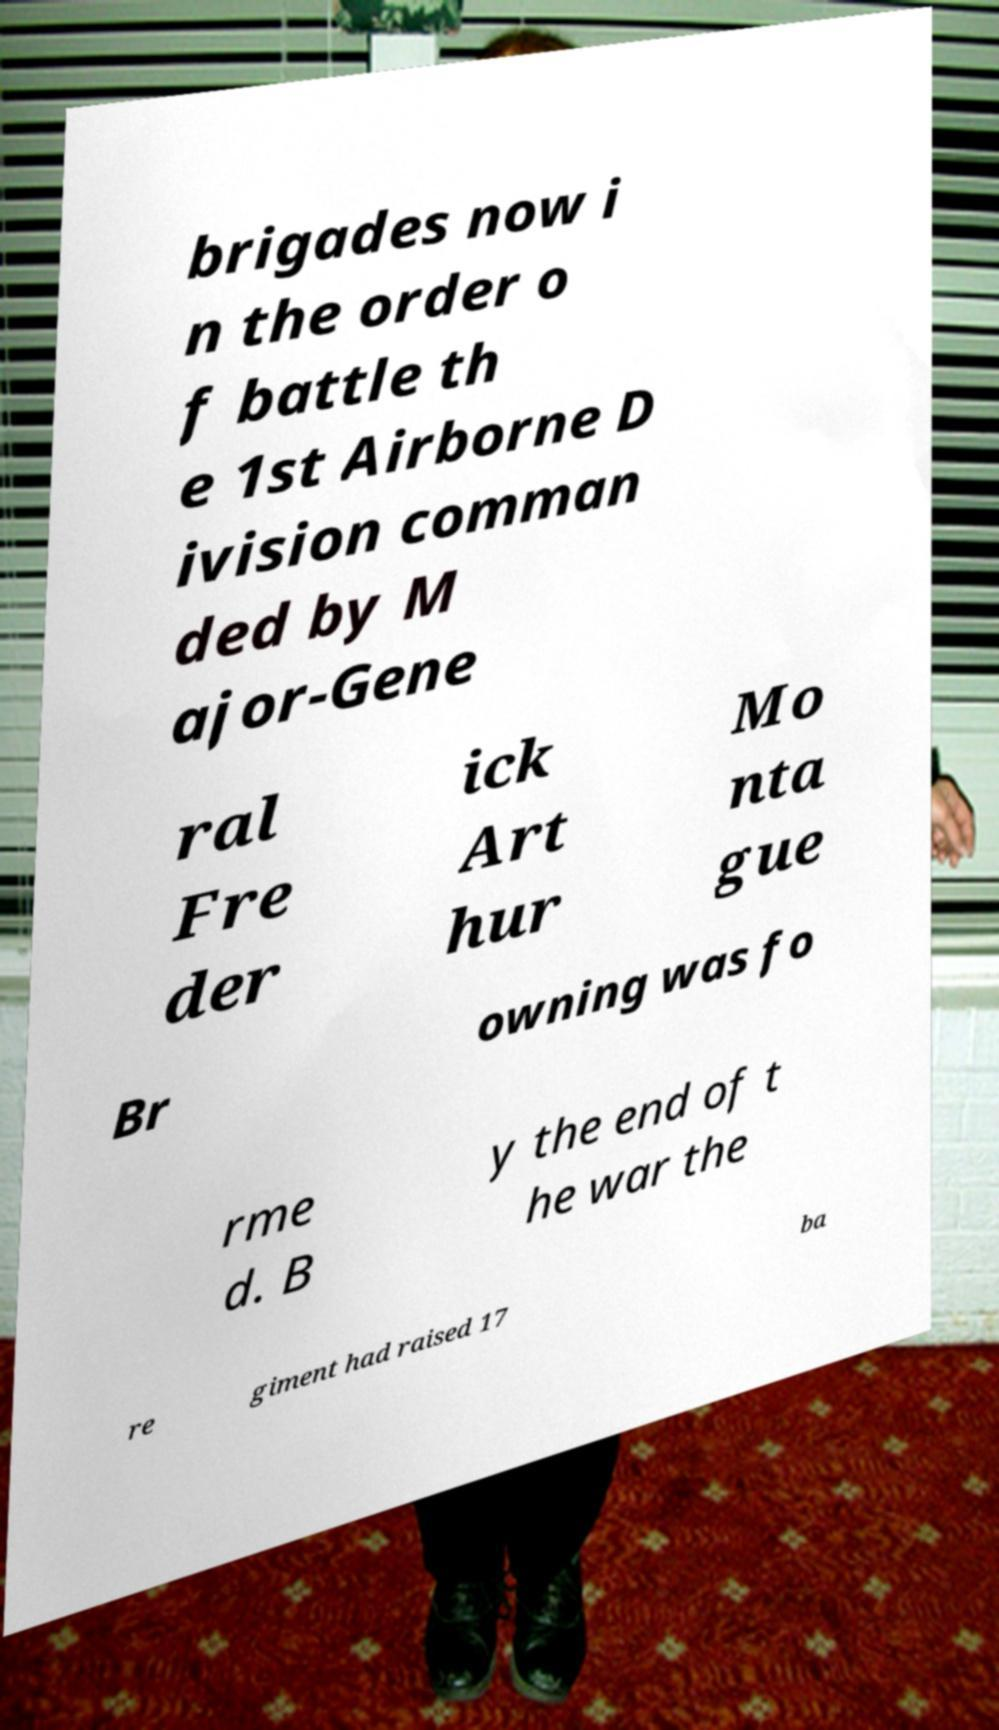For documentation purposes, I need the text within this image transcribed. Could you provide that? brigades now i n the order o f battle th e 1st Airborne D ivision comman ded by M ajor-Gene ral Fre der ick Art hur Mo nta gue Br owning was fo rme d. B y the end of t he war the re giment had raised 17 ba 